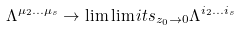Convert formula to latex. <formula><loc_0><loc_0><loc_500><loc_500>\Lambda ^ { \mu _ { 2 } \dots \mu _ { s } } \to \lim \lim i t s _ { z _ { 0 } \to 0 } \Lambda ^ { i _ { 2 } \dots i _ { s } }</formula> 